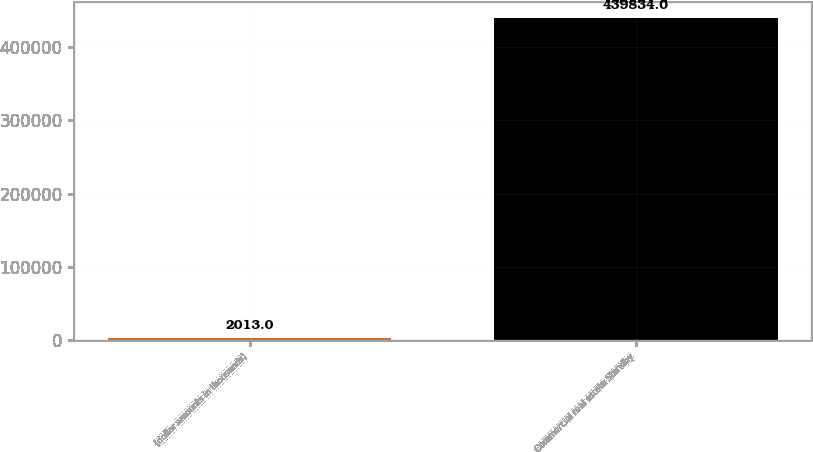Convert chart. <chart><loc_0><loc_0><loc_500><loc_500><bar_chart><fcel>(dollar amounts in thousands)<fcel>Commercial real estate Standby<nl><fcel>2013<fcel>439834<nl></chart> 